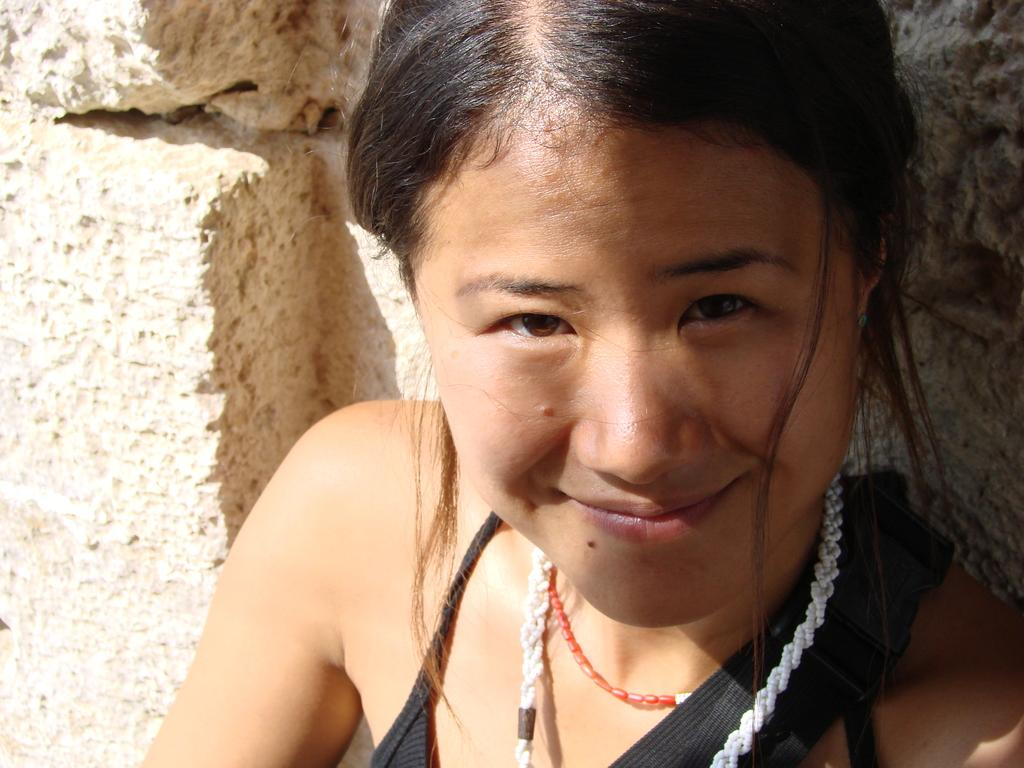Who is present in the image? There is a woman in the image. What is the woman wearing? The woman is wearing a black dress. Are there any accessories visible on the woman? Yes, the woman is wearing a necklace. What is the woman's facial expression in the image? The woman is smiling. What can be seen in the background of the image? There is a wall in the background of the image. What type of silver pies is the woman holding in the image? There is no silver or pies present in the image; it features a woman wearing a black dress, a necklace, and smiling. 